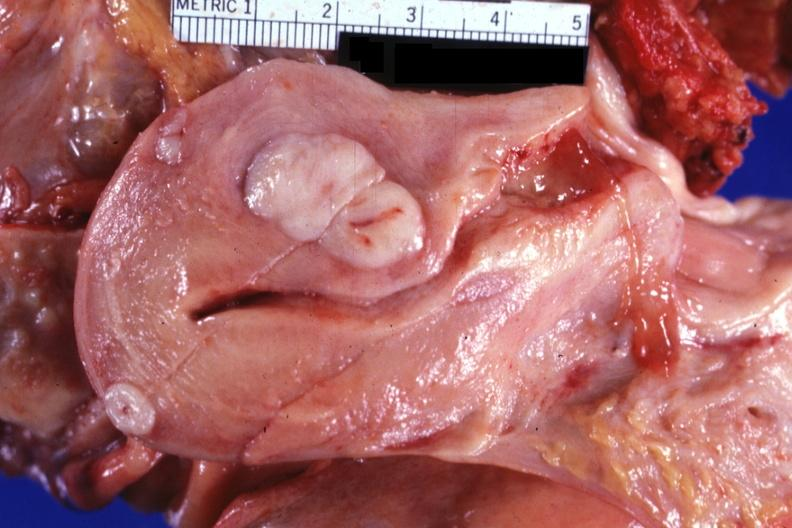what is present?
Answer the question using a single word or phrase. Female reproductive 